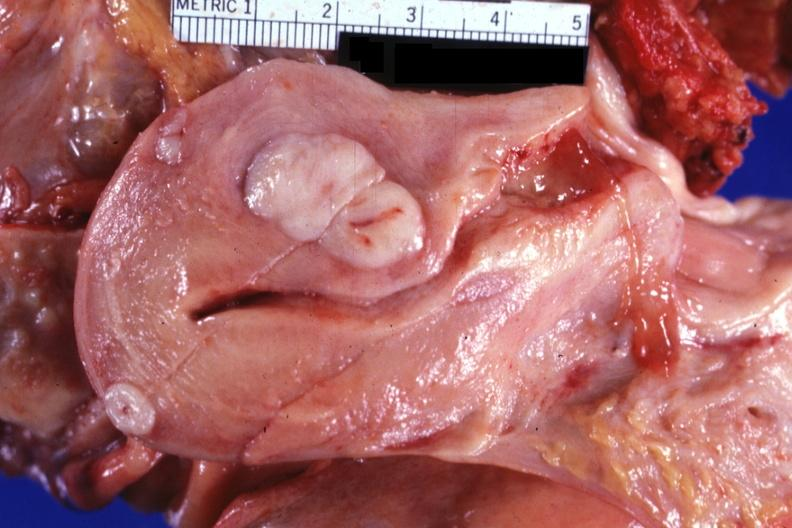what is present?
Answer the question using a single word or phrase. Female reproductive 